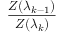<formula> <loc_0><loc_0><loc_500><loc_500>\frac { Z ( \lambda _ { k - 1 } ) } { Z ( \lambda _ { k } ) }</formula> 